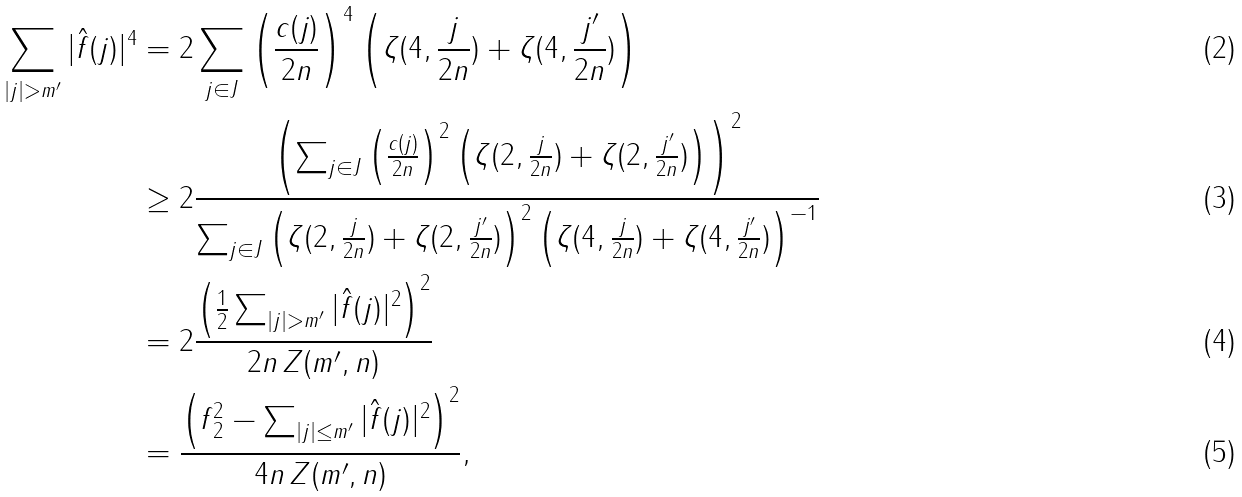<formula> <loc_0><loc_0><loc_500><loc_500>\sum _ { | j | > m ^ { \prime } } | \hat { f } ( j ) | ^ { 4 } & = 2 \sum _ { j \in J } \left ( \frac { c ( j ) } { 2 n } \right ) ^ { 4 } \left ( \zeta ( 4 , \frac { j } { 2 n } ) + \zeta ( 4 , \frac { j ^ { \prime } } { 2 n } ) \right ) \\ & \geq 2 \frac { \left ( \sum _ { j \in J } \left ( \frac { c ( j ) } { 2 n } \right ) ^ { 2 } \left ( \zeta ( 2 , \frac { j } { 2 n } ) + \zeta ( 2 , \frac { j ^ { \prime } } { 2 n } ) \right ) \right ) ^ { 2 } } { \sum _ { j \in J } { \left ( \zeta ( 2 , \frac { j } { 2 n } ) + \zeta ( 2 , \frac { j ^ { \prime } } { 2 n } ) \right ) ^ { 2 } } \left ( { \zeta ( 4 , \frac { j } { 2 n } ) + \zeta ( 4 , \frac { j ^ { \prime } } { 2 n } ) } \right ) ^ { - 1 } } \\ & = 2 \frac { \left ( \frac { 1 } { 2 } \sum _ { | j | > m ^ { \prime } } | \hat { f } ( j ) | ^ { 2 } \right ) ^ { 2 } } { 2 n \, Z ( m ^ { \prime } , n ) } \\ & = \frac { \left ( \| f \| _ { 2 } ^ { 2 } - \sum _ { | j | \leq m ^ { \prime } } | \hat { f } ( j ) | ^ { 2 } \right ) ^ { 2 } } { 4 n \, Z ( m ^ { \prime } , n ) } ,</formula> 